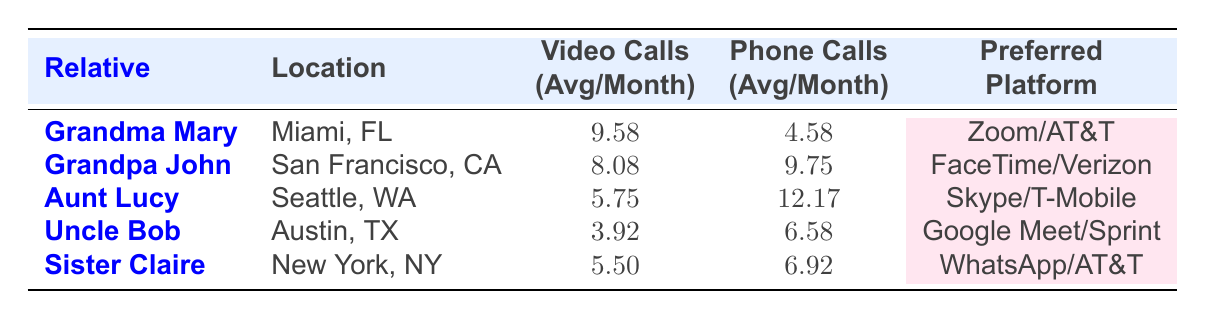What is Grandma Mary's average frequency of video calls per month? The table shows that Grandma Mary's video call frequency per month is recorded as 10, 8, 9, 12, 11, 10, 10, 7, 9, 10, 11, 8. Summing these values gives 9.58 (rounded to two decimal places) as the average after dividing by 12 months.
Answer: 9.58 Which relative has the highest average frequency of phone calls? The table provides the average phone call frequencies as follows: Grandpa John (9.75), Aunt Lucy (12.17), Uncle Bob (6.58), and Sister Claire (6.92). Aunt Lucy has the highest value at 12.17.
Answer: Aunt Lucy What is the preferred platform for video calls with Uncle Bob? The table specifies that Uncle Bob's preferred platform for video calls is Google Meet.
Answer: Google Meet What is the difference in the average frequency of video calls between Grandma Mary and Aunt Lucy? Grandma Mary's average frequency of video calls is 9.58, and Aunt Lucy's is 5.75. The difference is calculated by subtracting Aunt Lucy's frequency from Grandma Mary's: 9.58 - 5.75 = 3.83.
Answer: 3.83 Is it true that Sister Claire has more phone calls than video calls on average? By comparing the data, Sister Claire's average phone calls (6.92) are higher than her video calls (5.50). Therefore, it is true.
Answer: Yes What is the total average frequency of video calls and phone calls combined for Grandpa John? Grandpa John's average frequency of video calls is 8.08 and phone calls is 9.75. Summing these gives 8.08 + 9.75 = 17.83 as the total average.
Answer: 17.83 Which relative communicates more through phone calls than video calls, and by how much? Analyzing the average frequencies: Grandma Mary (4.58, 9.58), Grandpa John (9.75, 8.08), Aunt Lucy (12.17, 5.75), Uncle Bob (6.58, 3.92), and Sister Claire (6.92, 5.50). Aunt Lucy has the highest difference of 6.42 (12.17 - 5.75).
Answer: Aunt Lucy, 6.42 What is the average frequency of video calls for all relatives combined? First, calculate the average video call frequencies: 9.58 (Grandma) + 8.08 (Grandpa) + 5.75 (Aunt) + 3.92 (Uncle) + 5.50 (Sister) = 32.83. Then divide by 5 to get the average: 32.83 / 5 = 6.566.
Answer: 6.57 Between video calls and phone calls, which method has a larger cumulative frequency across all relatives? The total frequencies for video calls (sum of 9.58, 8.08, 5.75, 3.92, 5.50) = 32.83, while for phone calls (sum of 4.58, 9.75, 12.17, 6.58, 6.92) = 40. This shows phone calls have higher cumulative frequency.
Answer: Phone calls How often does Uncle Bob communicate through both methods on average? Uncle Bob's average video calls are 3.92, and his phone calls are 6.58. The total is 3.92 + 6.58 = 10.50, averaged across both methods.
Answer: 10.50 